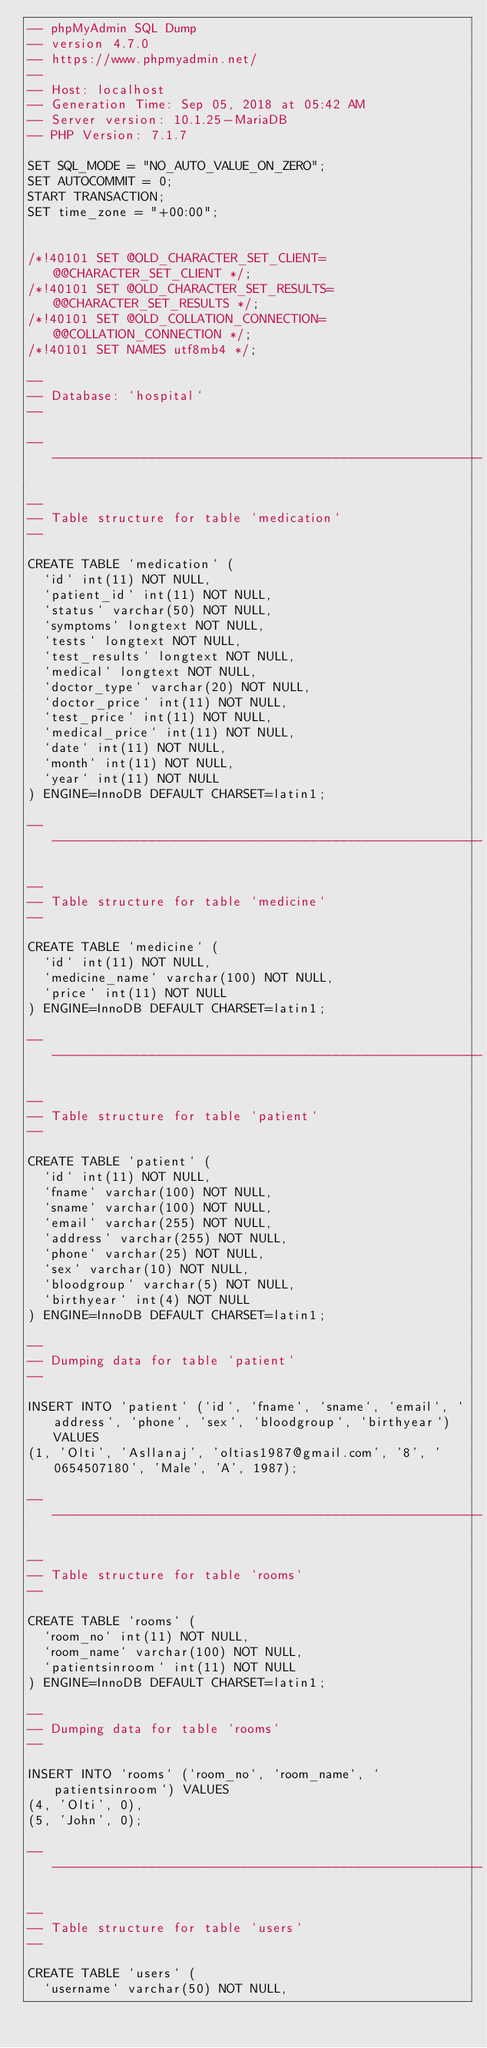<code> <loc_0><loc_0><loc_500><loc_500><_SQL_>-- phpMyAdmin SQL Dump
-- version 4.7.0
-- https://www.phpmyadmin.net/
--
-- Host: localhost
-- Generation Time: Sep 05, 2018 at 05:42 AM
-- Server version: 10.1.25-MariaDB
-- PHP Version: 7.1.7

SET SQL_MODE = "NO_AUTO_VALUE_ON_ZERO";
SET AUTOCOMMIT = 0;
START TRANSACTION;
SET time_zone = "+00:00";


/*!40101 SET @OLD_CHARACTER_SET_CLIENT=@@CHARACTER_SET_CLIENT */;
/*!40101 SET @OLD_CHARACTER_SET_RESULTS=@@CHARACTER_SET_RESULTS */;
/*!40101 SET @OLD_COLLATION_CONNECTION=@@COLLATION_CONNECTION */;
/*!40101 SET NAMES utf8mb4 */;

--
-- Database: `hospital`
--

-- --------------------------------------------------------

--
-- Table structure for table `medication`
--

CREATE TABLE `medication` (
  `id` int(11) NOT NULL,
  `patient_id` int(11) NOT NULL,
  `status` varchar(50) NOT NULL,
  `symptoms` longtext NOT NULL,
  `tests` longtext NOT NULL,
  `test_results` longtext NOT NULL,
  `medical` longtext NOT NULL,
  `doctor_type` varchar(20) NOT NULL,
  `doctor_price` int(11) NOT NULL,
  `test_price` int(11) NOT NULL,
  `medical_price` int(11) NOT NULL,
  `date` int(11) NOT NULL,
  `month` int(11) NOT NULL,
  `year` int(11) NOT NULL
) ENGINE=InnoDB DEFAULT CHARSET=latin1;

-- --------------------------------------------------------

--
-- Table structure for table `medicine`
--

CREATE TABLE `medicine` (
  `id` int(11) NOT NULL,
  `medicine_name` varchar(100) NOT NULL,
  `price` int(11) NOT NULL
) ENGINE=InnoDB DEFAULT CHARSET=latin1;

-- --------------------------------------------------------

--
-- Table structure for table `patient`
--

CREATE TABLE `patient` (
  `id` int(11) NOT NULL,
  `fname` varchar(100) NOT NULL,
  `sname` varchar(100) NOT NULL,
  `email` varchar(255) NOT NULL,
  `address` varchar(255) NOT NULL,
  `phone` varchar(25) NOT NULL,
  `sex` varchar(10) NOT NULL,
  `bloodgroup` varchar(5) NOT NULL,
  `birthyear` int(4) NOT NULL
) ENGINE=InnoDB DEFAULT CHARSET=latin1;

--
-- Dumping data for table `patient`
--

INSERT INTO `patient` (`id`, `fname`, `sname`, `email`, `address`, `phone`, `sex`, `bloodgroup`, `birthyear`) VALUES
(1, 'Olti', 'Asllanaj', 'oltias1987@gmail.com', '8', '0654507180', 'Male', 'A', 1987);

-- --------------------------------------------------------

--
-- Table structure for table `rooms`
--

CREATE TABLE `rooms` (
  `room_no` int(11) NOT NULL,
  `room_name` varchar(100) NOT NULL,
  `patientsinroom` int(11) NOT NULL
) ENGINE=InnoDB DEFAULT CHARSET=latin1;

--
-- Dumping data for table `rooms`
--

INSERT INTO `rooms` (`room_no`, `room_name`, `patientsinroom`) VALUES
(4, 'Olti', 0),
(5, 'John', 0);

-- --------------------------------------------------------

--
-- Table structure for table `users`
--

CREATE TABLE `users` (
  `username` varchar(50) NOT NULL,</code> 